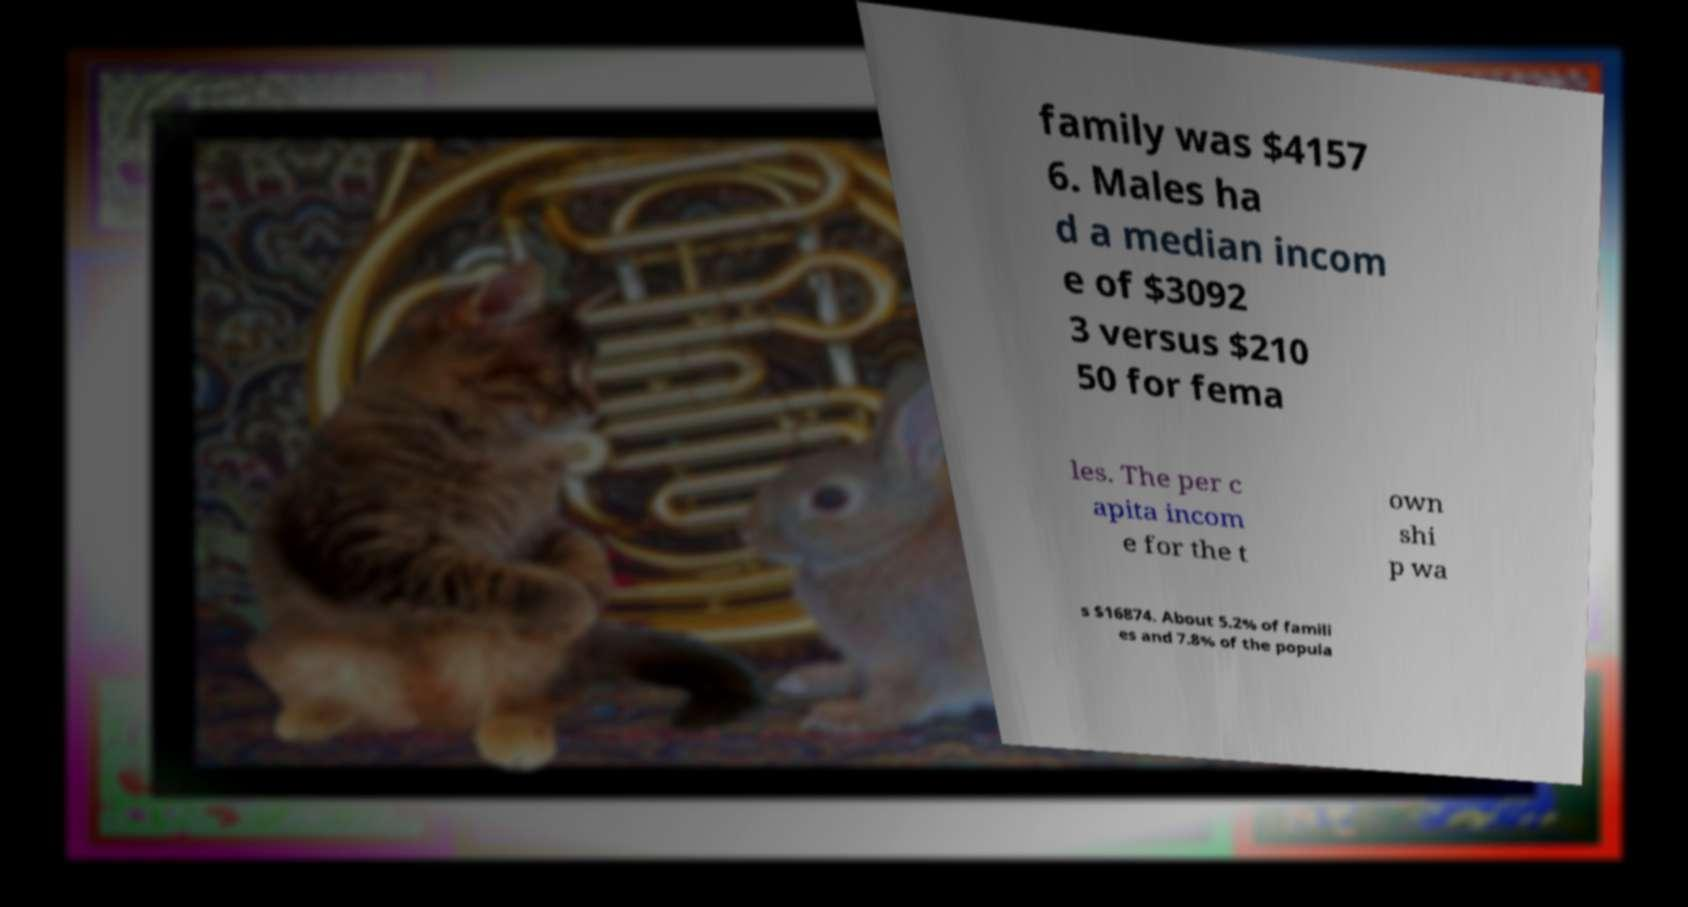There's text embedded in this image that I need extracted. Can you transcribe it verbatim? family was $4157 6. Males ha d a median incom e of $3092 3 versus $210 50 for fema les. The per c apita incom e for the t own shi p wa s $16874. About 5.2% of famili es and 7.8% of the popula 